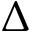Convert formula to latex. <formula><loc_0><loc_0><loc_500><loc_500>\Delta</formula> 